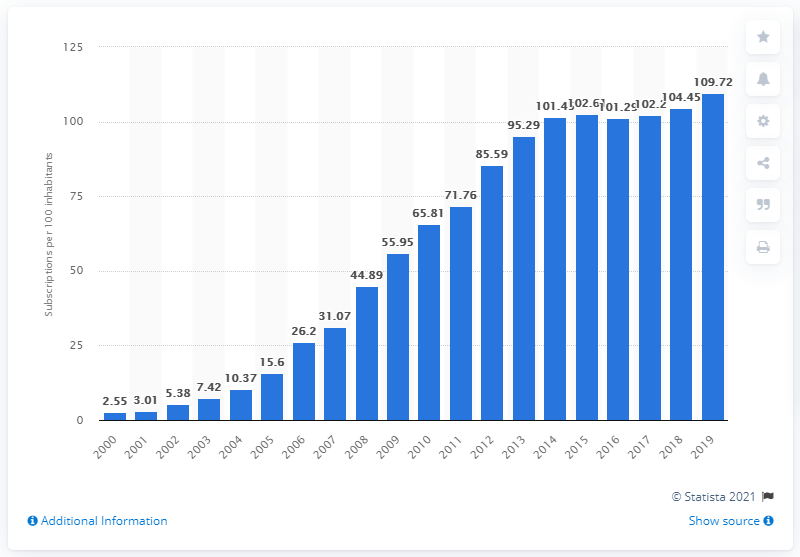Outline some significant characteristics in this image. In the year 2000, there were a certain number of mobile cellular subscriptions per 100 inhabitants in Senegal. In Senegal between 2000 and 2019, there were an average of 109.72 mobile subscriptions for every 100 people. 